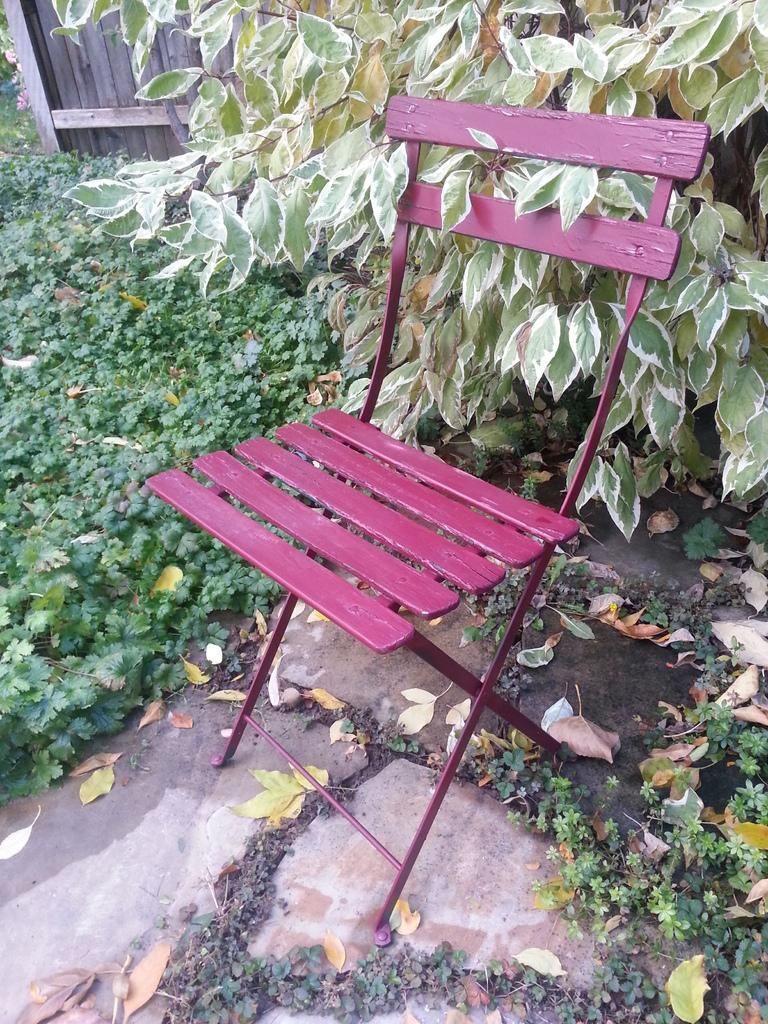What type of object is located towards the right side of the image? There is a plant truncated towards the right of the image. What type of furniture can be seen in the image? There is a chair in the image. What type of objects are located towards the left side of the image? There are plants truncated towards the left of the image. What type of material is used for the wall in the image? There is a wooden wall truncated in the image. How many boats are visible in the image? There are no boats present in the image. What type of house is depicted in the image? The image does not show a house; it features a plant, a chair, and a wooden wall. 